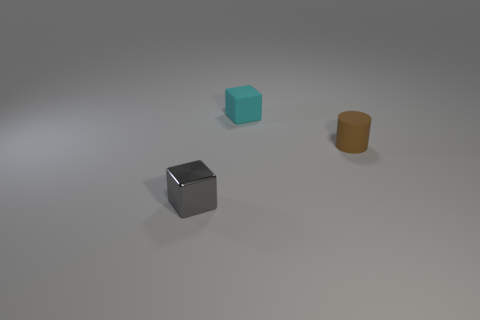Add 1 tiny cubes. How many objects exist? 4 Subtract all blocks. How many objects are left? 1 Add 3 small matte blocks. How many small matte blocks are left? 4 Add 1 small matte cubes. How many small matte cubes exist? 2 Subtract 0 purple cylinders. How many objects are left? 3 Subtract all tiny purple cubes. Subtract all brown cylinders. How many objects are left? 2 